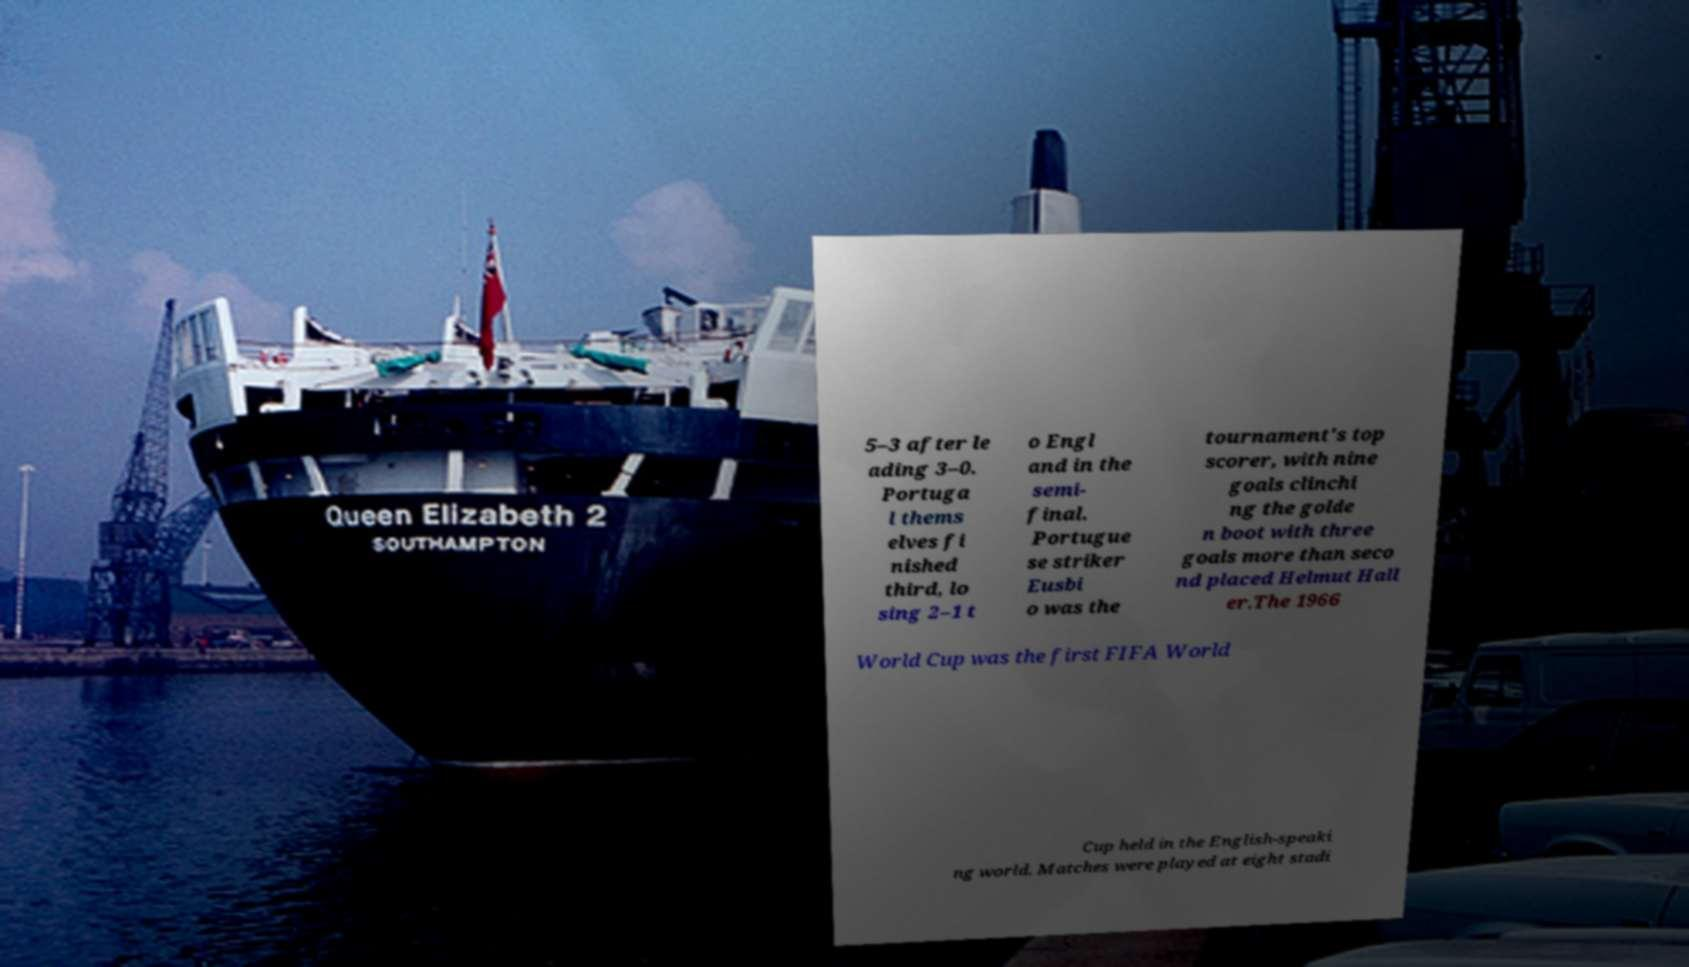For documentation purposes, I need the text within this image transcribed. Could you provide that? 5–3 after le ading 3–0. Portuga l thems elves fi nished third, lo sing 2–1 t o Engl and in the semi- final. Portugue se striker Eusbi o was the tournament's top scorer, with nine goals clinchi ng the golde n boot with three goals more than seco nd placed Helmut Hall er.The 1966 World Cup was the first FIFA World Cup held in the English-speaki ng world. Matches were played at eight stadi 